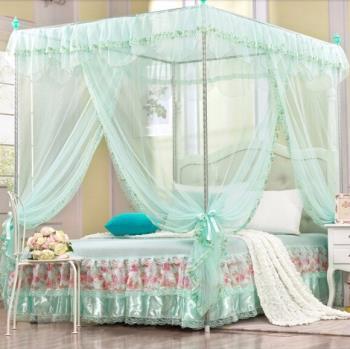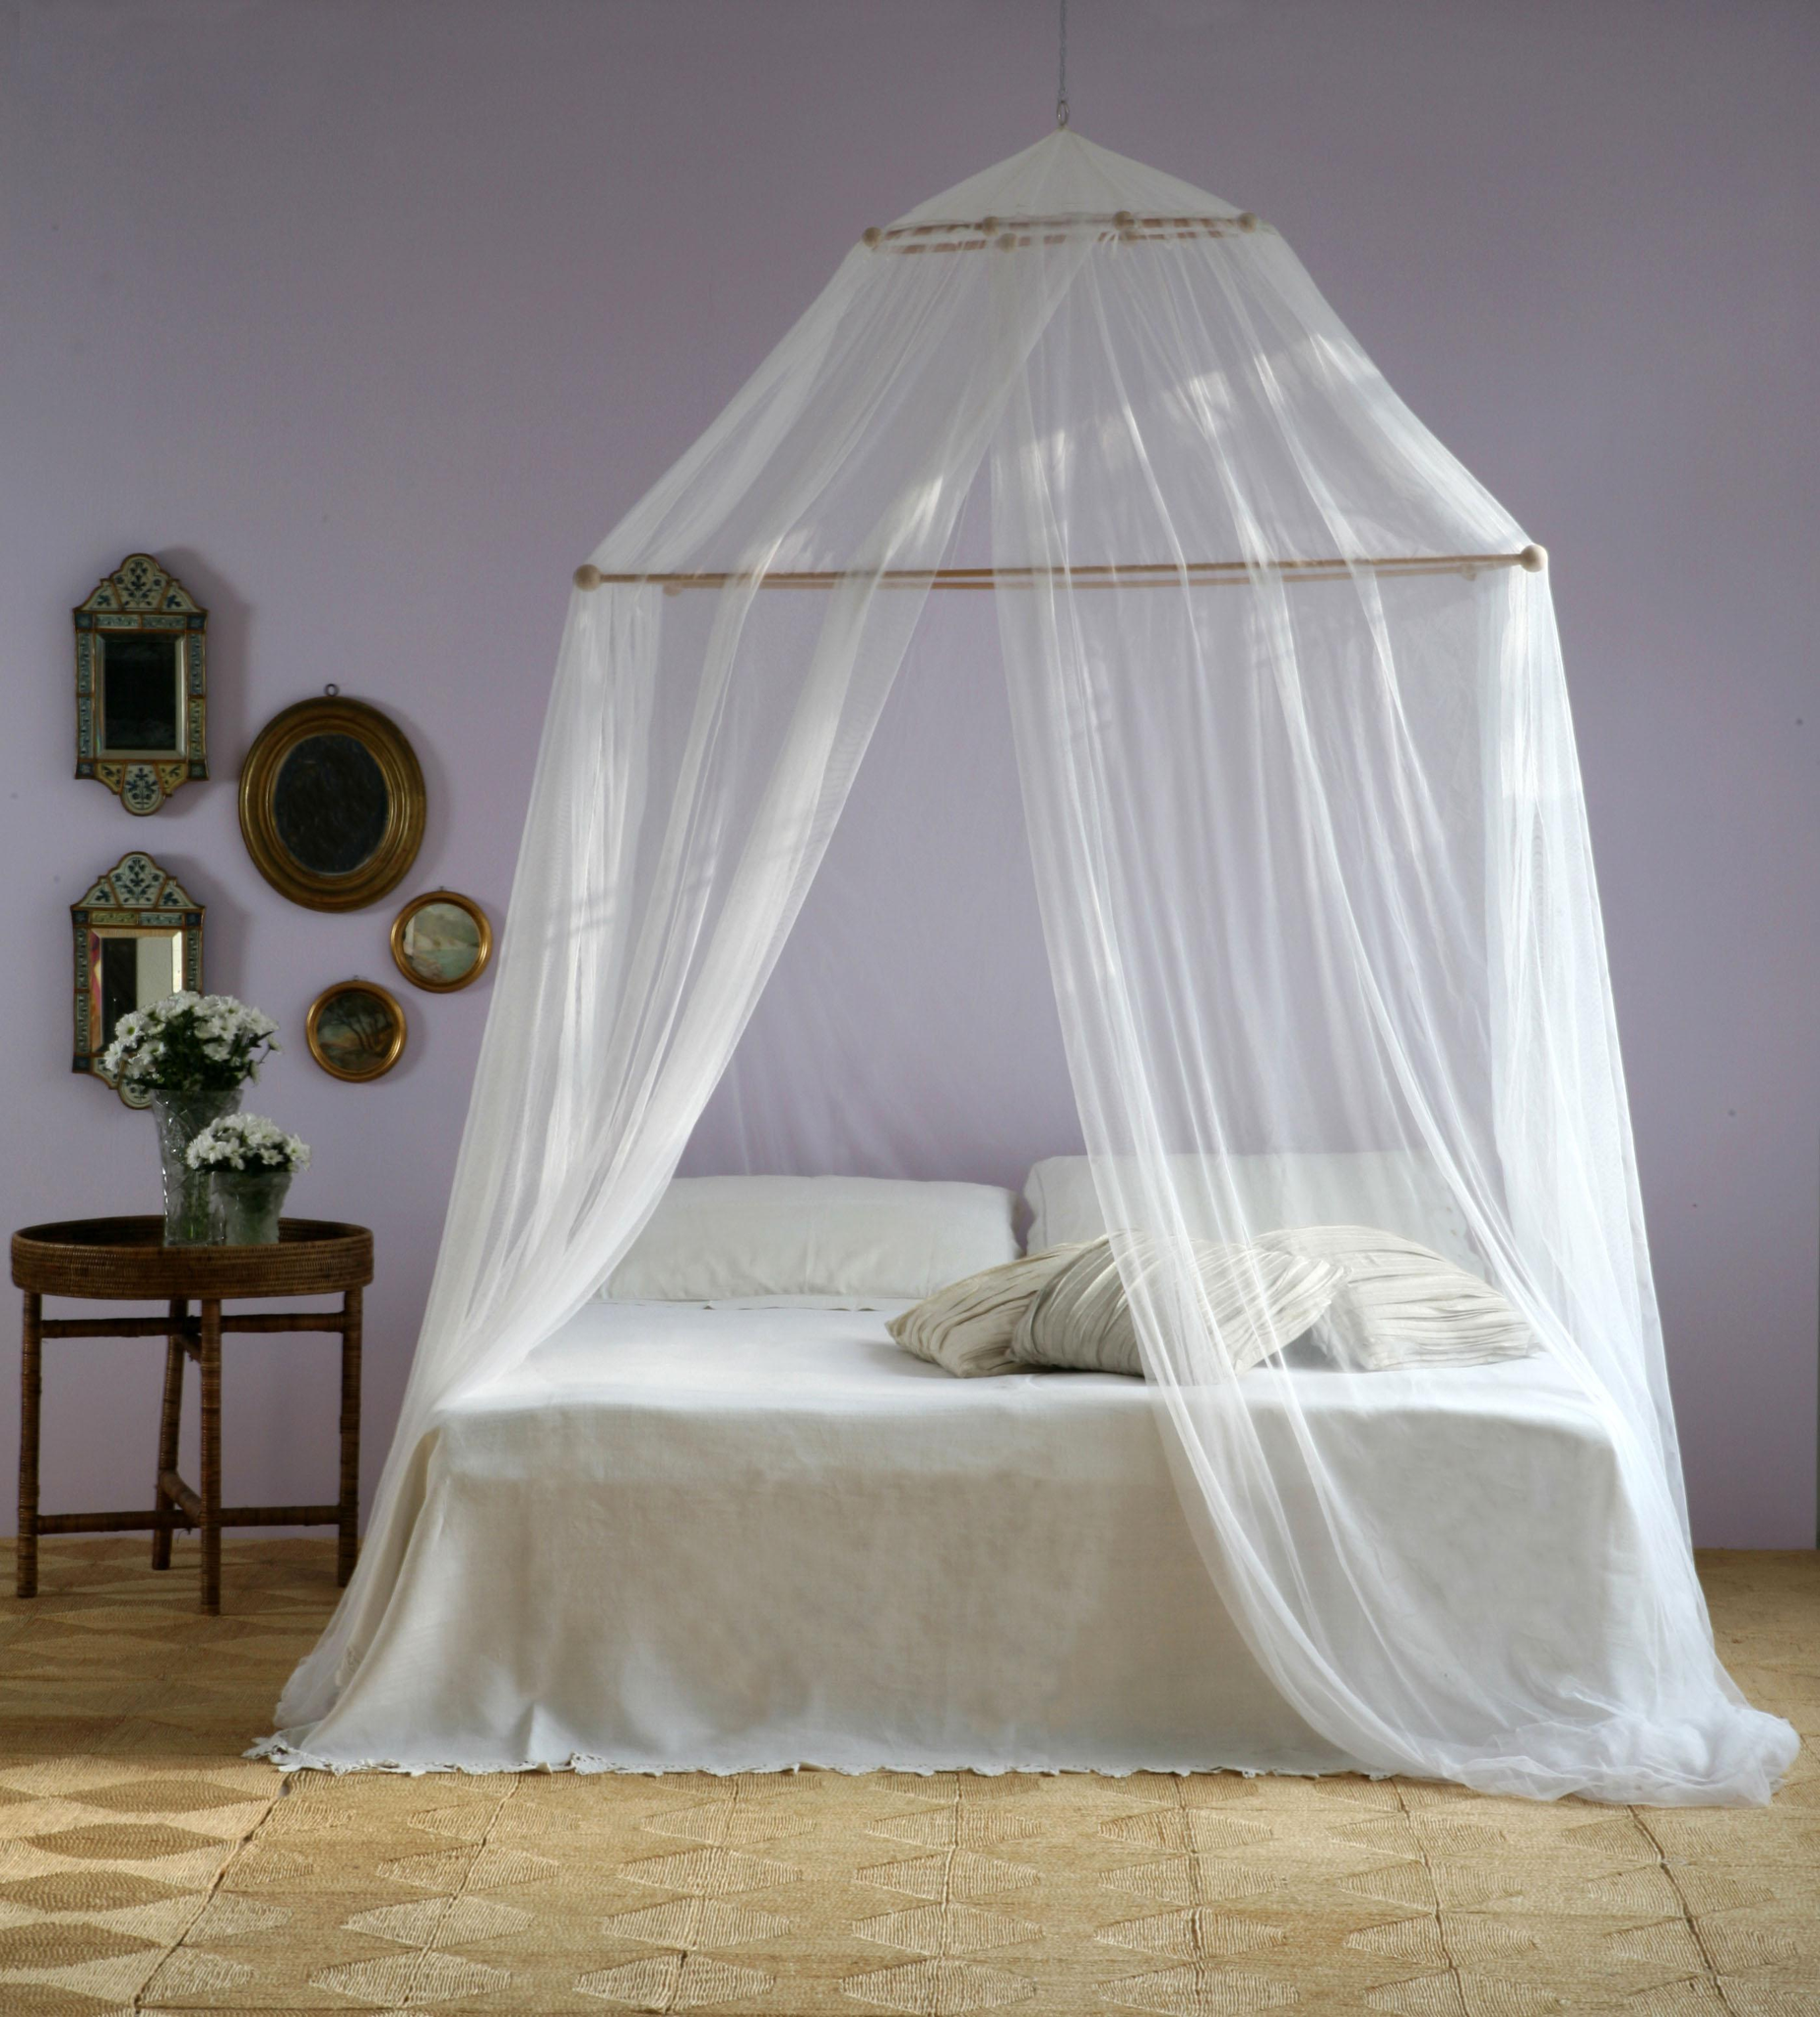The first image is the image on the left, the second image is the image on the right. For the images displayed, is the sentence "A bed has an aqua colored canopy that is gathered at the four posts." factually correct? Answer yes or no. Yes. The first image is the image on the left, the second image is the image on the right. For the images displayed, is the sentence "Green bed drapes are tied on to bed poles." factually correct? Answer yes or no. Yes. 